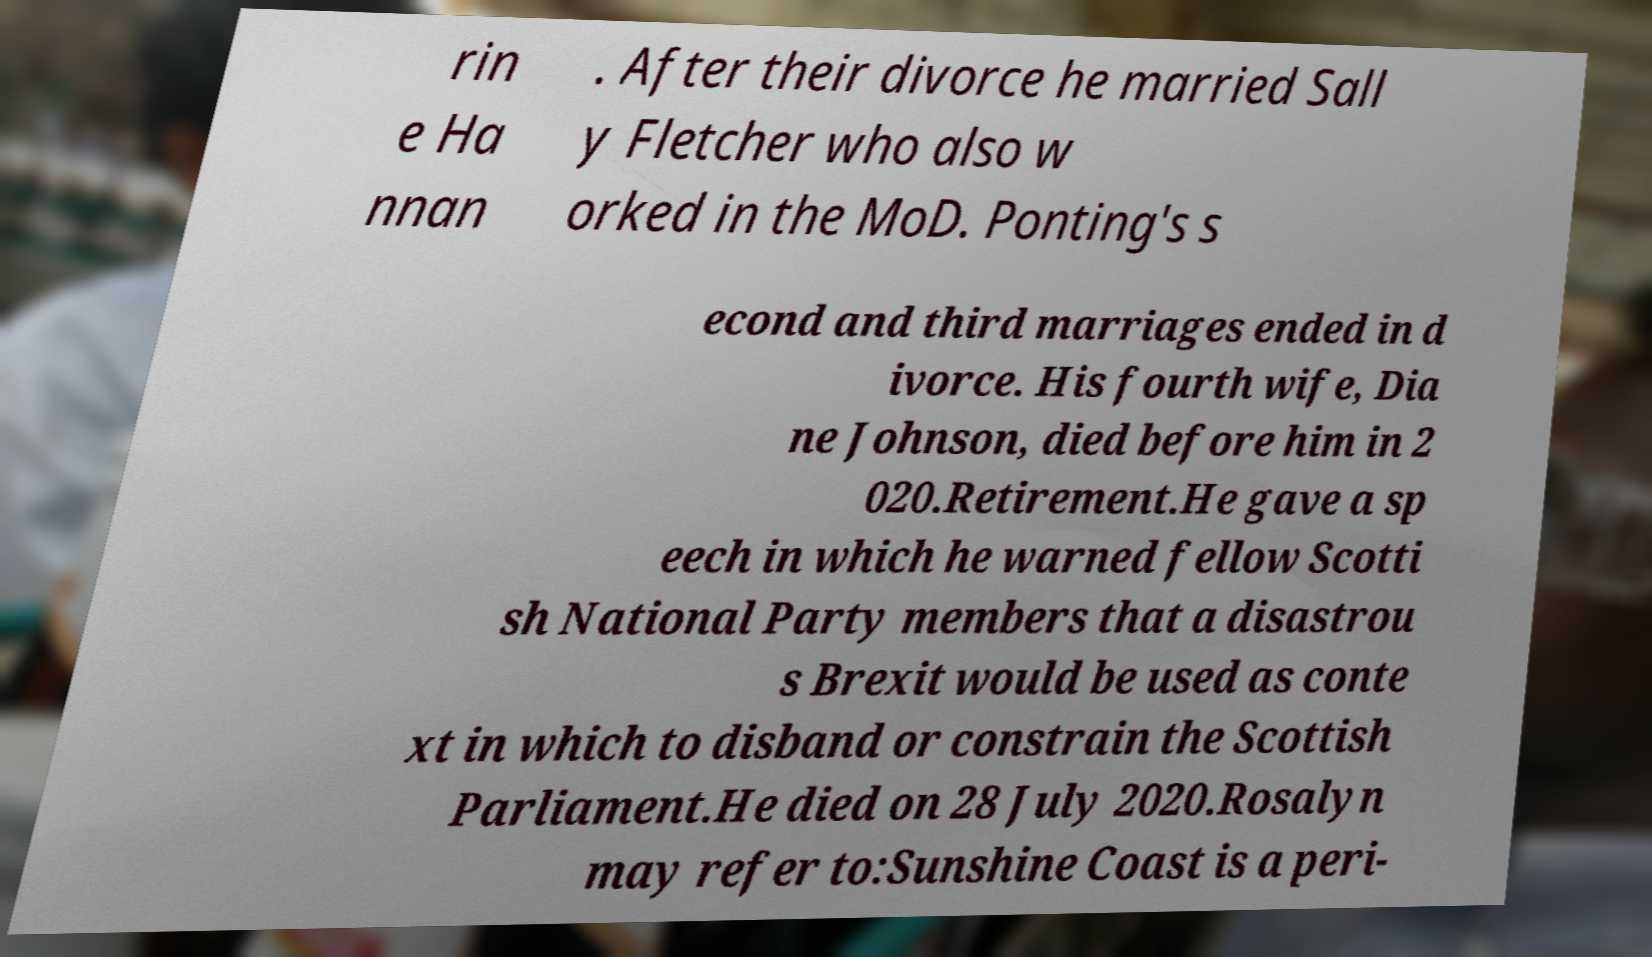There's text embedded in this image that I need extracted. Can you transcribe it verbatim? rin e Ha nnan . After their divorce he married Sall y Fletcher who also w orked in the MoD. Ponting's s econd and third marriages ended in d ivorce. His fourth wife, Dia ne Johnson, died before him in 2 020.Retirement.He gave a sp eech in which he warned fellow Scotti sh National Party members that a disastrou s Brexit would be used as conte xt in which to disband or constrain the Scottish Parliament.He died on 28 July 2020.Rosalyn may refer to:Sunshine Coast is a peri- 